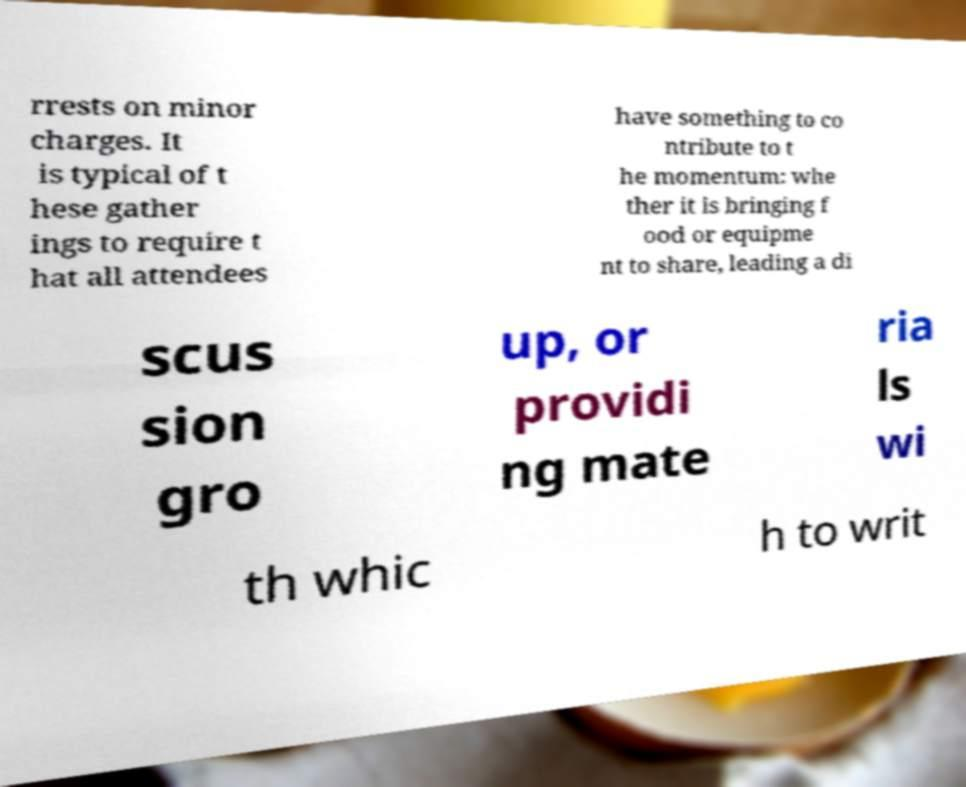Please identify and transcribe the text found in this image. rrests on minor charges. It is typical of t hese gather ings to require t hat all attendees have something to co ntribute to t he momentum: whe ther it is bringing f ood or equipme nt to share, leading a di scus sion gro up, or providi ng mate ria ls wi th whic h to writ 